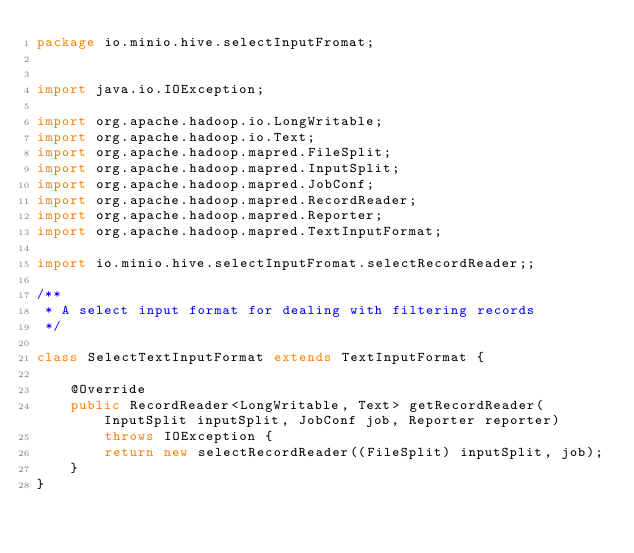Convert code to text. <code><loc_0><loc_0><loc_500><loc_500><_Java_>package io.minio.hive.selectInputFromat;


import java.io.IOException;

import org.apache.hadoop.io.LongWritable;
import org.apache.hadoop.io.Text;
import org.apache.hadoop.mapred.FileSplit;
import org.apache.hadoop.mapred.InputSplit;
import org.apache.hadoop.mapred.JobConf;
import org.apache.hadoop.mapred.RecordReader;
import org.apache.hadoop.mapred.Reporter;
import org.apache.hadoop.mapred.TextInputFormat;

import io.minio.hive.selectInputFromat.selectRecordReader;;

/**
 * A select input format for dealing with filtering records
 */

class SelectTextInputFormat extends TextInputFormat {

    @Override
    public RecordReader<LongWritable, Text> getRecordReader(InputSplit inputSplit, JobConf job, Reporter reporter)
        throws IOException {
        return new selectRecordReader((FileSplit) inputSplit, job);
    }
}
</code> 